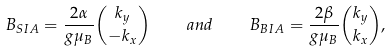<formula> <loc_0><loc_0><loc_500><loc_500>B _ { S I A } = \frac { 2 \alpha } { g \mu _ { B } } \binom { k _ { y } } { - k _ { x } } \quad a n d \quad B _ { B I A } = \frac { 2 \beta } { g \mu _ { B } } \binom { k _ { y } } { k _ { x } } ,</formula> 